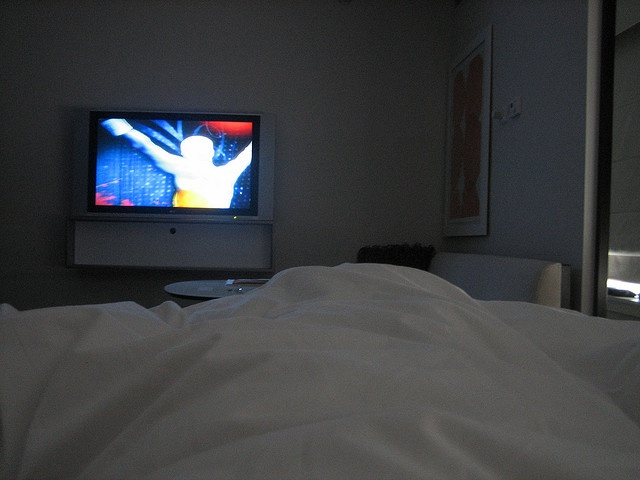Describe the objects in this image and their specific colors. I can see bed in black and gray tones, tv in black, white, navy, and blue tones, and chair in black and gray tones in this image. 